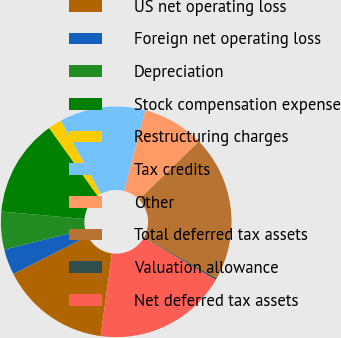<chart> <loc_0><loc_0><loc_500><loc_500><pie_chart><fcel>US net operating loss<fcel>Foreign net operating loss<fcel>Depreciation<fcel>Stock compensation expense<fcel>Restructuring charges<fcel>Tax credits<fcel>Other<fcel>Total deferred tax assets<fcel>Valuation allowance<fcel>Net deferred tax assets<nl><fcel>15.39%<fcel>3.6%<fcel>5.29%<fcel>13.7%<fcel>1.92%<fcel>12.02%<fcel>8.65%<fcel>20.44%<fcel>0.23%<fcel>18.75%<nl></chart> 